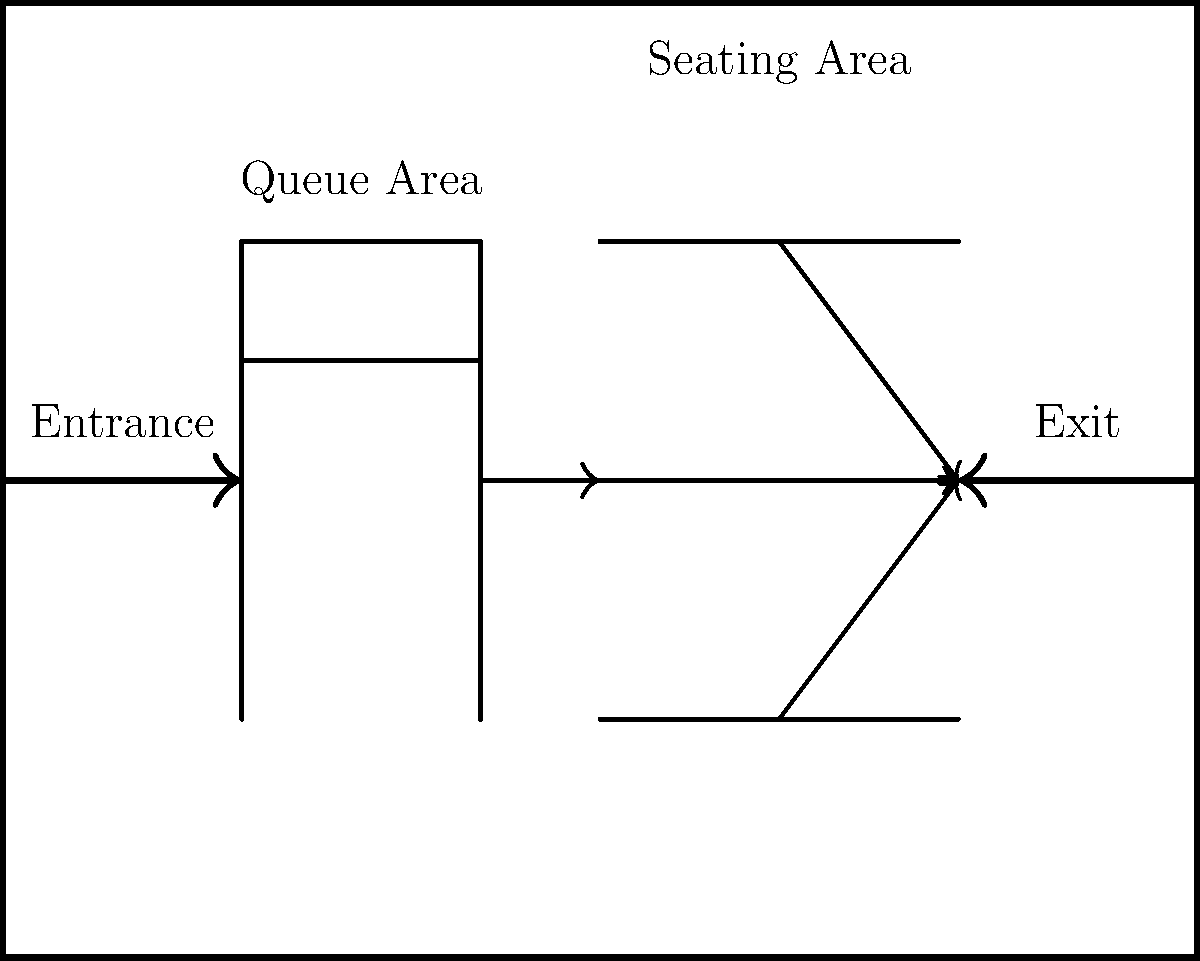Based on the diagram of the fashion show venue layout, what is the maximum number of distinct queue lines that can be formed in the designated queue area while maintaining an efficient flow into the seating area? To determine the maximum number of distinct queue lines that can be formed in the designated queue area, we need to analyze the diagram and consider the efficient flow into the seating area. Let's break it down step-by-step:

1. Observe the entrance: The diagram shows an entrance arrow on the left side of the venue.

2. Identify the queue area: There is a designated queue area immediately after the entrance, represented by rectangular shapes.

3. Analyze the queue structure: The queue area is depicted with two distinct rectangular shapes, one inside the other.

4. Consider the flow: There is an arrow showing the flow from the queue area to the seating area.

5. Evaluate efficiency: To maintain an efficient flow, we want to maximize the number of queues while ensuring they can smoothly merge into the single flow towards the seating area.

6. Count the queue lines: The diagram shows two rectangular shapes in the queue area, which suggests that two distinct queue lines can be formed:
   a. One queue line following the outer rectangle
   b. One queue line following the inner rectangle

7. Assess additional possibilities: Adding more queue lines within this structure would likely cause congestion and reduce efficiency when merging into the single flow towards the seating area.

Therefore, based on the given diagram and considering the need for efficient flow, the maximum number of distinct queue lines that can be formed is 2.
Answer: 2 queue lines 